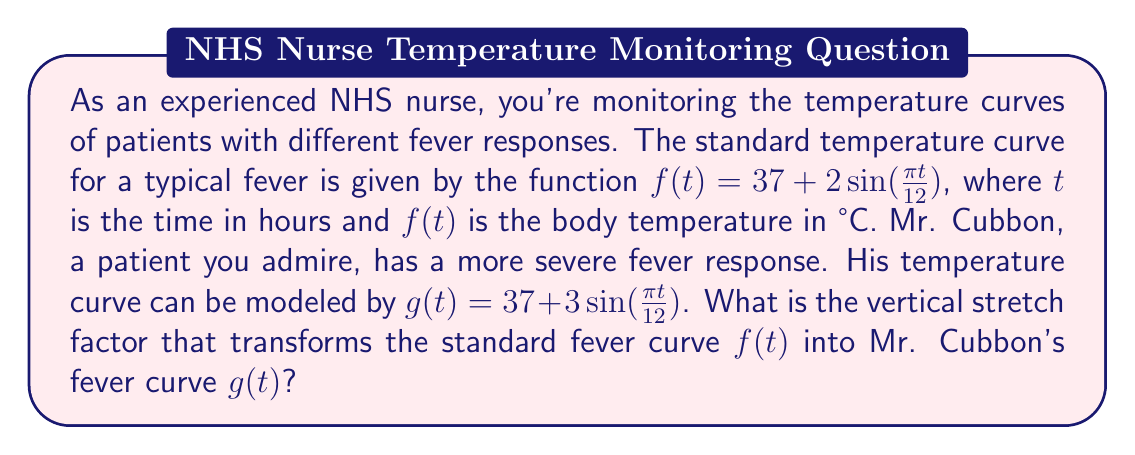What is the answer to this math problem? To solve this problem, we need to analyze the vertical stretch of the temperature curves. Let's approach this step-by-step:

1) The general form of a sinusoidal function is:
   $$ y = A\sin(B(x-C)) + D $$
   where $A$ is the amplitude, $B$ affects the period, $C$ is the phase shift, and $D$ is the vertical shift.

2) For the standard fever curve $f(t)$:
   $$ f(t) = 37 + 2\sin(\frac{\pi t}{12}) $$
   The amplitude is 2.

3) For Mr. Cubbon's fever curve $g(t)$:
   $$ g(t) = 37 + 3\sin(\frac{\pi t}{12}) $$
   The amplitude is 3.

4) The vertical stretch factor is the ratio of the new amplitude to the original amplitude:
   $$ \text{Vertical stretch factor} = \frac{\text{New amplitude}}{\text{Original amplitude}} = \frac{3}{2} = 1.5 $$

5) We can verify this by expressing $g(t)$ in terms of $f(t)$:
   $$ g(t) = 37 + 3\sin(\frac{\pi t}{12}) = 37 + 1.5(2\sin(\frac{\pi t}{12})) = 37 + 1.5(f(t) - 37) = 1.5f(t) - 18.5 $$

This confirms that $g(t)$ is indeed a vertical stretch of $f(t)$ by a factor of 1.5, followed by a vertical shift to maintain the same baseline temperature of 37°C.
Answer: The vertical stretch factor is 1.5. 